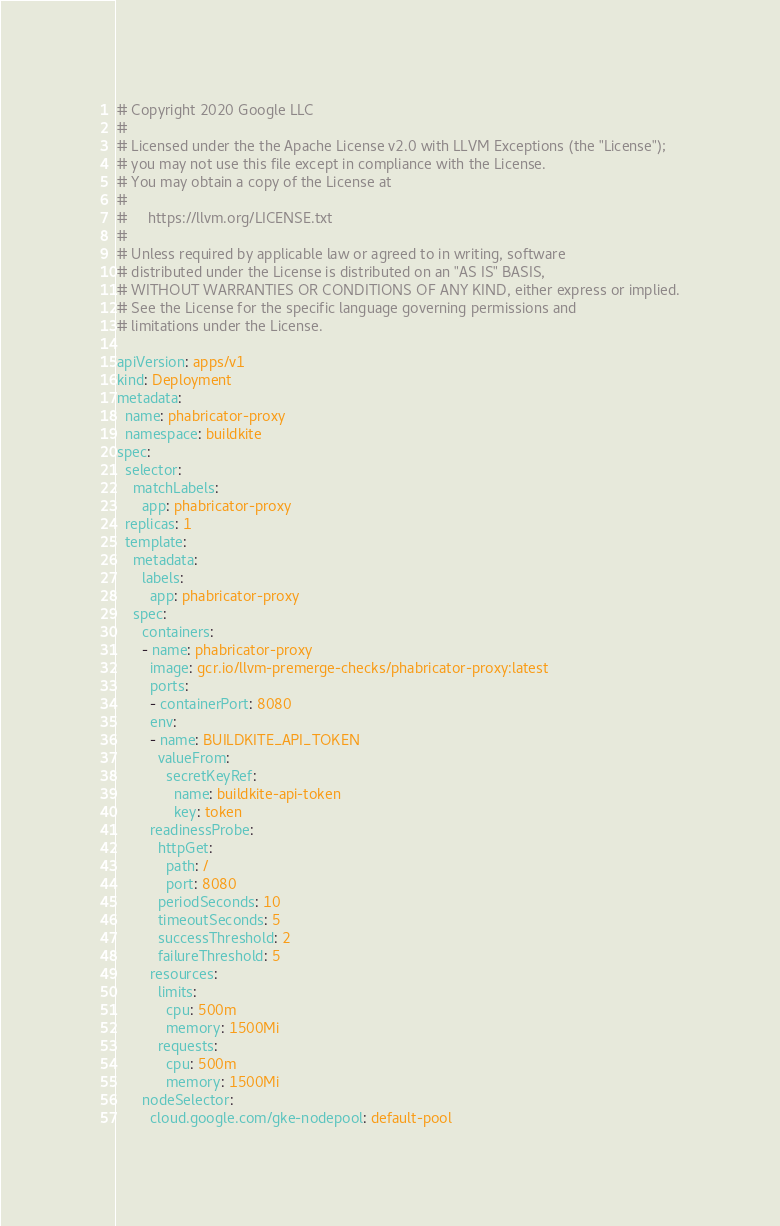<code> <loc_0><loc_0><loc_500><loc_500><_YAML_># Copyright 2020 Google LLC
#
# Licensed under the the Apache License v2.0 with LLVM Exceptions (the "License");
# you may not use this file except in compliance with the License.
# You may obtain a copy of the License at
#
#     https://llvm.org/LICENSE.txt
#
# Unless required by applicable law or agreed to in writing, software
# distributed under the License is distributed on an "AS IS" BASIS,
# WITHOUT WARRANTIES OR CONDITIONS OF ANY KIND, either express or implied.
# See the License for the specific language governing permissions and
# limitations under the License.

apiVersion: apps/v1
kind: Deployment
metadata:
  name: phabricator-proxy
  namespace: buildkite
spec:
  selector:
    matchLabels:
      app: phabricator-proxy
  replicas: 1
  template:
    metadata:
      labels:
        app: phabricator-proxy
    spec:
      containers:
      - name: phabricator-proxy
        image: gcr.io/llvm-premerge-checks/phabricator-proxy:latest
        ports:
        - containerPort: 8080
        env:
        - name: BUILDKITE_API_TOKEN
          valueFrom:
            secretKeyRef:
              name: buildkite-api-token
              key: token
        readinessProbe:
          httpGet:
            path: /
            port: 8080
          periodSeconds: 10
          timeoutSeconds: 5
          successThreshold: 2
          failureThreshold: 5
        resources:
          limits:
            cpu: 500m
            memory: 1500Mi
          requests:
            cpu: 500m
            memory: 1500Mi
      nodeSelector:
        cloud.google.com/gke-nodepool: default-pool
</code> 